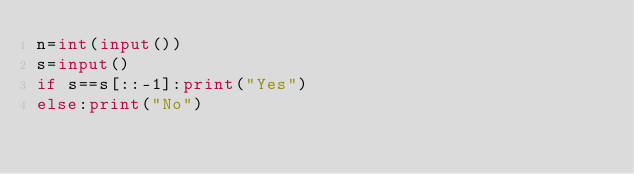<code> <loc_0><loc_0><loc_500><loc_500><_Python_>n=int(input())
s=input()
if s==s[::-1]:print("Yes")
else:print("No")</code> 